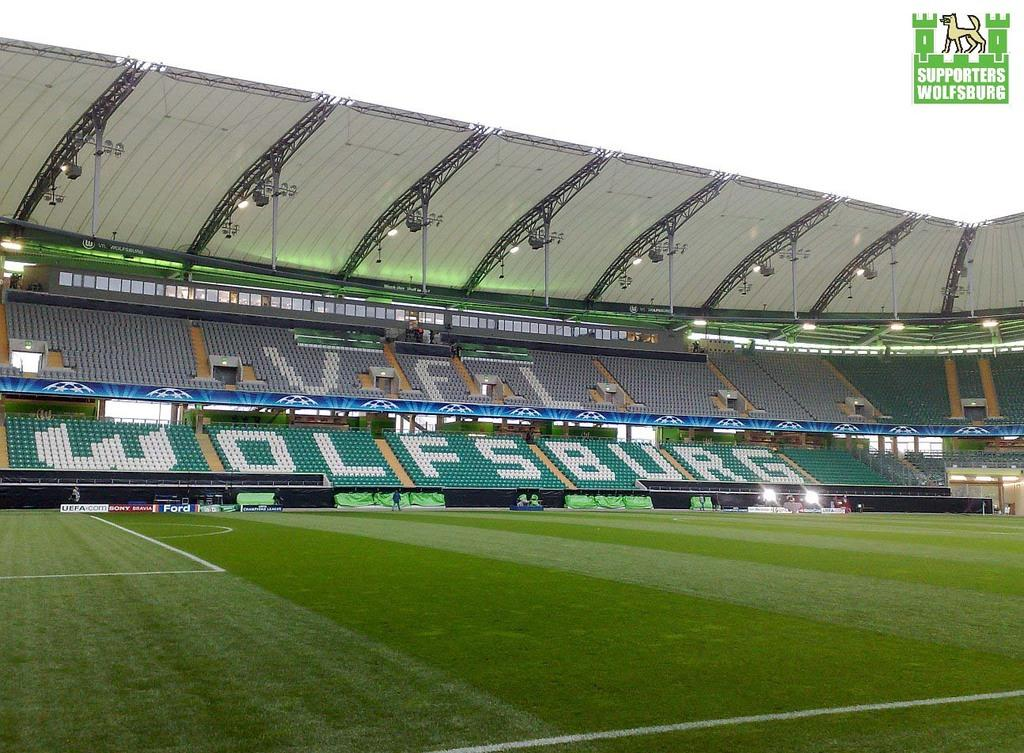<image>
Give a short and clear explanation of the subsequent image. The outdoor sports stadium at Wolfsburg is currently empty. 